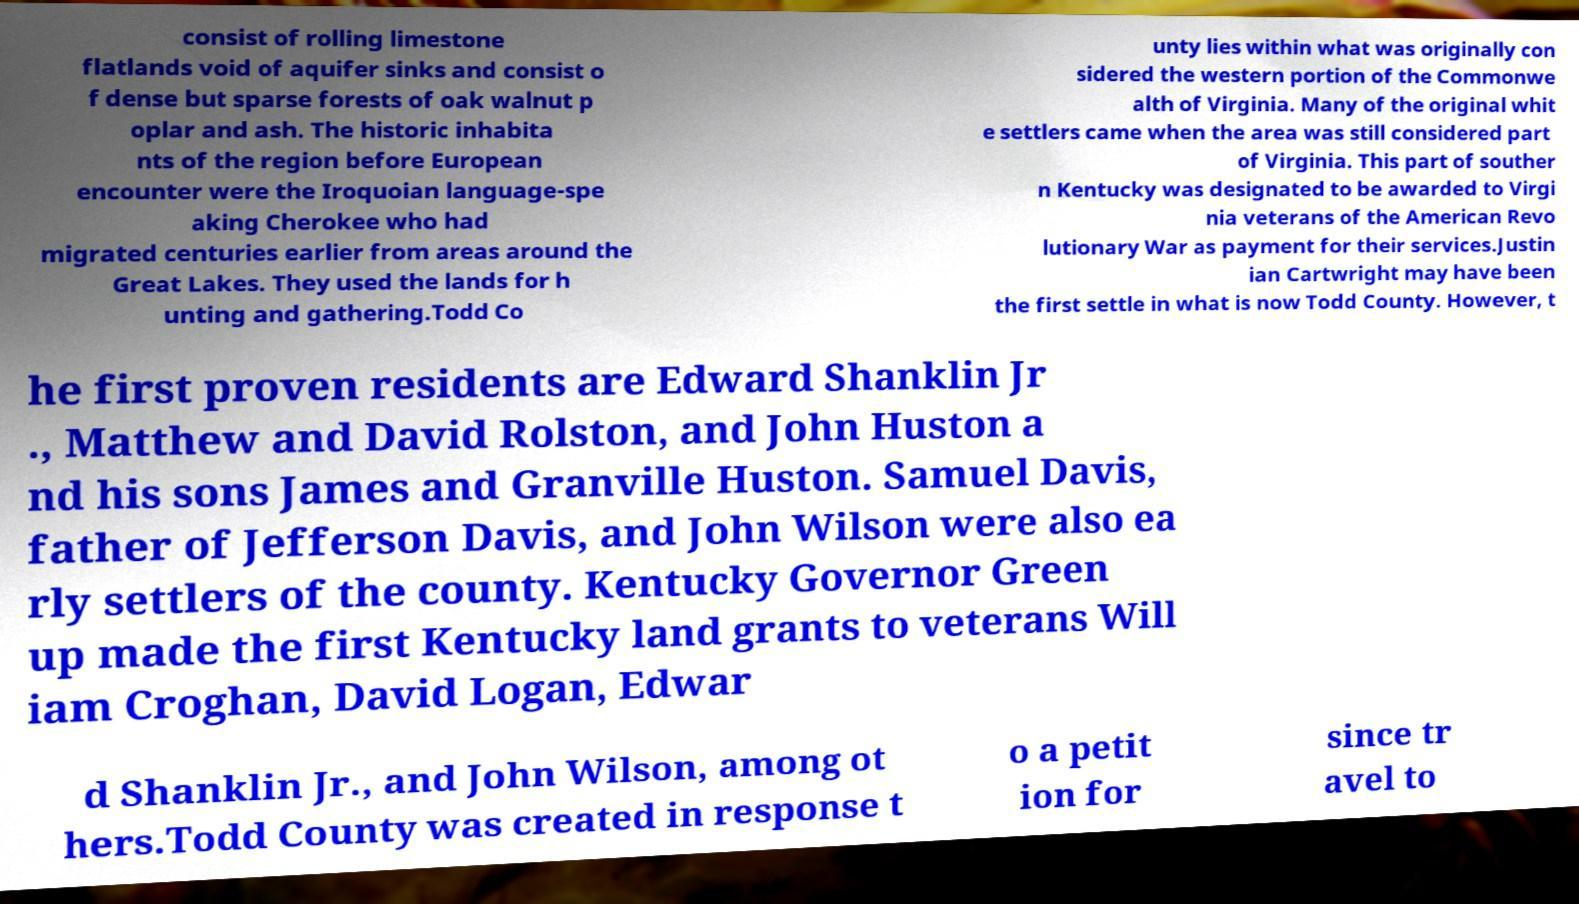There's text embedded in this image that I need extracted. Can you transcribe it verbatim? consist of rolling limestone flatlands void of aquifer sinks and consist o f dense but sparse forests of oak walnut p oplar and ash. The historic inhabita nts of the region before European encounter were the Iroquoian language-spe aking Cherokee who had migrated centuries earlier from areas around the Great Lakes. They used the lands for h unting and gathering.Todd Co unty lies within what was originally con sidered the western portion of the Commonwe alth of Virginia. Many of the original whit e settlers came when the area was still considered part of Virginia. This part of souther n Kentucky was designated to be awarded to Virgi nia veterans of the American Revo lutionary War as payment for their services.Justin ian Cartwright may have been the first settle in what is now Todd County. However, t he first proven residents are Edward Shanklin Jr ., Matthew and David Rolston, and John Huston a nd his sons James and Granville Huston. Samuel Davis, father of Jefferson Davis, and John Wilson were also ea rly settlers of the county. Kentucky Governor Green up made the first Kentucky land grants to veterans Will iam Croghan, David Logan, Edwar d Shanklin Jr., and John Wilson, among ot hers.Todd County was created in response t o a petit ion for since tr avel to 